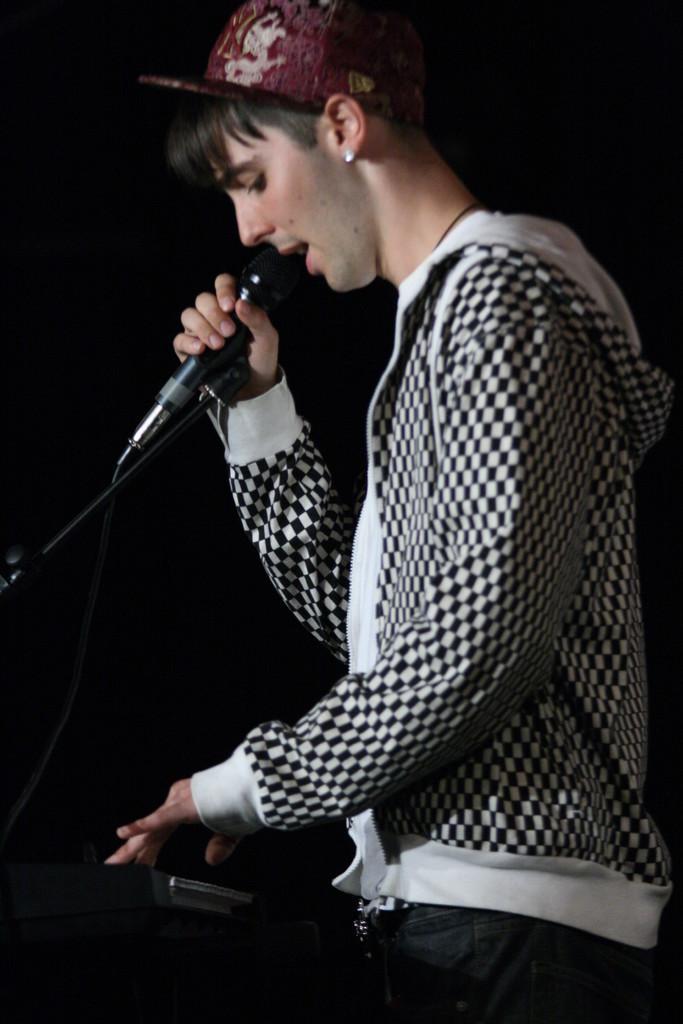How would you summarize this image in a sentence or two? In this image I can see a person standing and holding a microphone. He is wearing a cap and a checkered hoodie. There is a black background. 